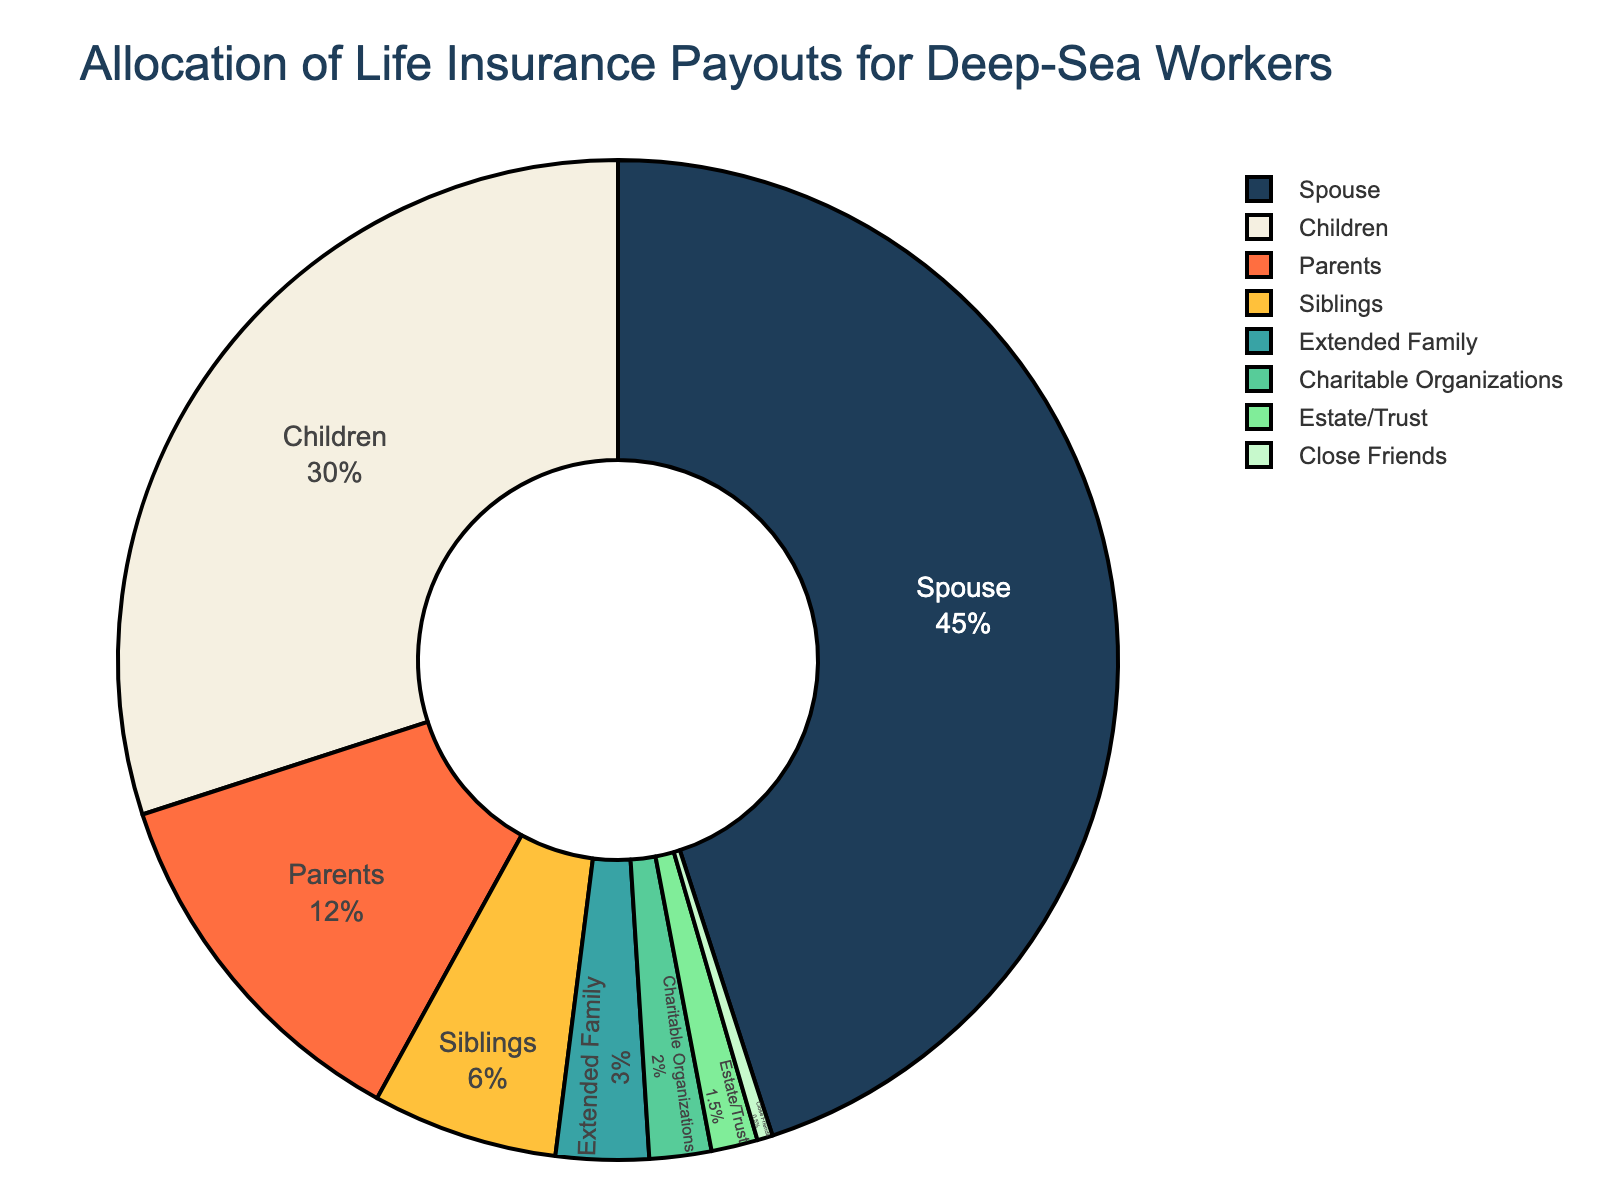What's the largest category of life insurance payouts? The figure shows different categories of life insurance payouts with their respective percentages. The largest percentage will indicate the largest category. According to the pie chart, the spouse category has the highest percentage at 45%.
Answer: Spouse Which category receives a 30% allocation of life insurance payouts? The figure includes different categories with their corresponding allocation percentages. By identifying which category has a 30% allocation, we see that it is the children category.
Answer: Children How much more percentage does the spouse category receive compared to the siblings category? Identify the percentages for both the spouse and siblings categories, which are 45% and 6%, respectively. Subtract the percentage of the siblings category from the spouse category: 45% - 6% = 39%.
Answer: 39% What is the combined percentage allocation for parents and children? Locate the percentages for the parents and children categories in the chart, which are 12% and 30% respectively. Add these two percentages together: 12% + 30% = 42%.
Answer: 42% Which category has the smallest allocation of life insurance payouts? The smallest allocation would be the category with the lowest percentage value. According to the pie chart, the category with the smallest allocation is close friends at 0.5%.
Answer: Close Friends How many percentage points more is allocated to parents than extended family? The percentage for the parents category is 12%, and for extended family, it is 3%. Subtract the larger percentage from the smaller one: 12% - 3% = 9%.
Answer: 9% What is the total percentage allocated to the extended family, charitable organizations, and estate/trust combined? Find the individual percentages for these categories: extended family (3%), charitable organizations (2%), and estate/trust (1.5%). Add these together: 3% + 2% + 1.5% = 6.5%.
Answer: 6.5% Which category is indicated with a blue color in the chart? By referring to the visual attributes of the pie chart, we see that the charitable organizations category is indicated with a blue color.
Answer: Charitable Organizations What’s the percentage difference between the children category and the estate/trust category? Identify the percentages for children (30%) and estate/trust (1.5%). Subtract the smaller percentage from the larger one: 30% - 1.5% = 28.5%.
Answer: 28.5% Is the allocation for close friends greater than, less than, or equal to that of charitable organizations? By comparing the percentages for close friends (0.5%) and charitable organizations (2%), we see that the allocation for close friends is less than that of charitable organizations.
Answer: Less Than 